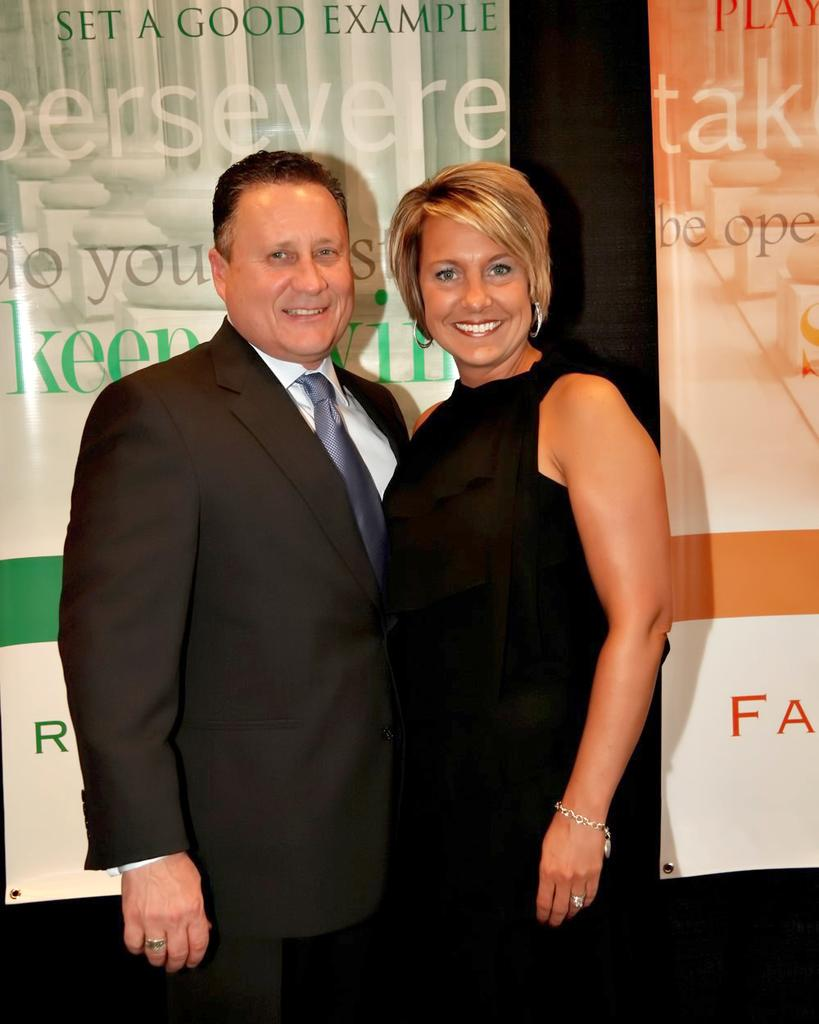Who are the two people in the center of the image? There is a man and a lady in the center of the image. What are the man and the lady doing in the image? The man and the lady are standing and smiling. What can be seen in the background of the image? There are banners in the background of the image. What type of toothpaste is being advertised on the banners in the image? There is no toothpaste or advertisement present on the banners in the image. How does the sleet affect the man and the lady in the image? There is no mention of sleet in the image, so it does not affect the man and the lady. 